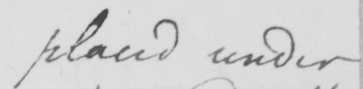Please provide the text content of this handwritten line. placed under 